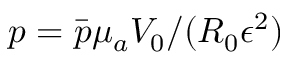Convert formula to latex. <formula><loc_0><loc_0><loc_500><loc_500>p = \bar { p } { \mu } _ { a } V _ { 0 } / ( R _ { 0 } { \epsilon } ^ { 2 } )</formula> 